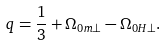Convert formula to latex. <formula><loc_0><loc_0><loc_500><loc_500>q = \frac { 1 } { 3 } + \Omega _ { 0 m \perp } - \Omega _ { 0 H \perp } .</formula> 